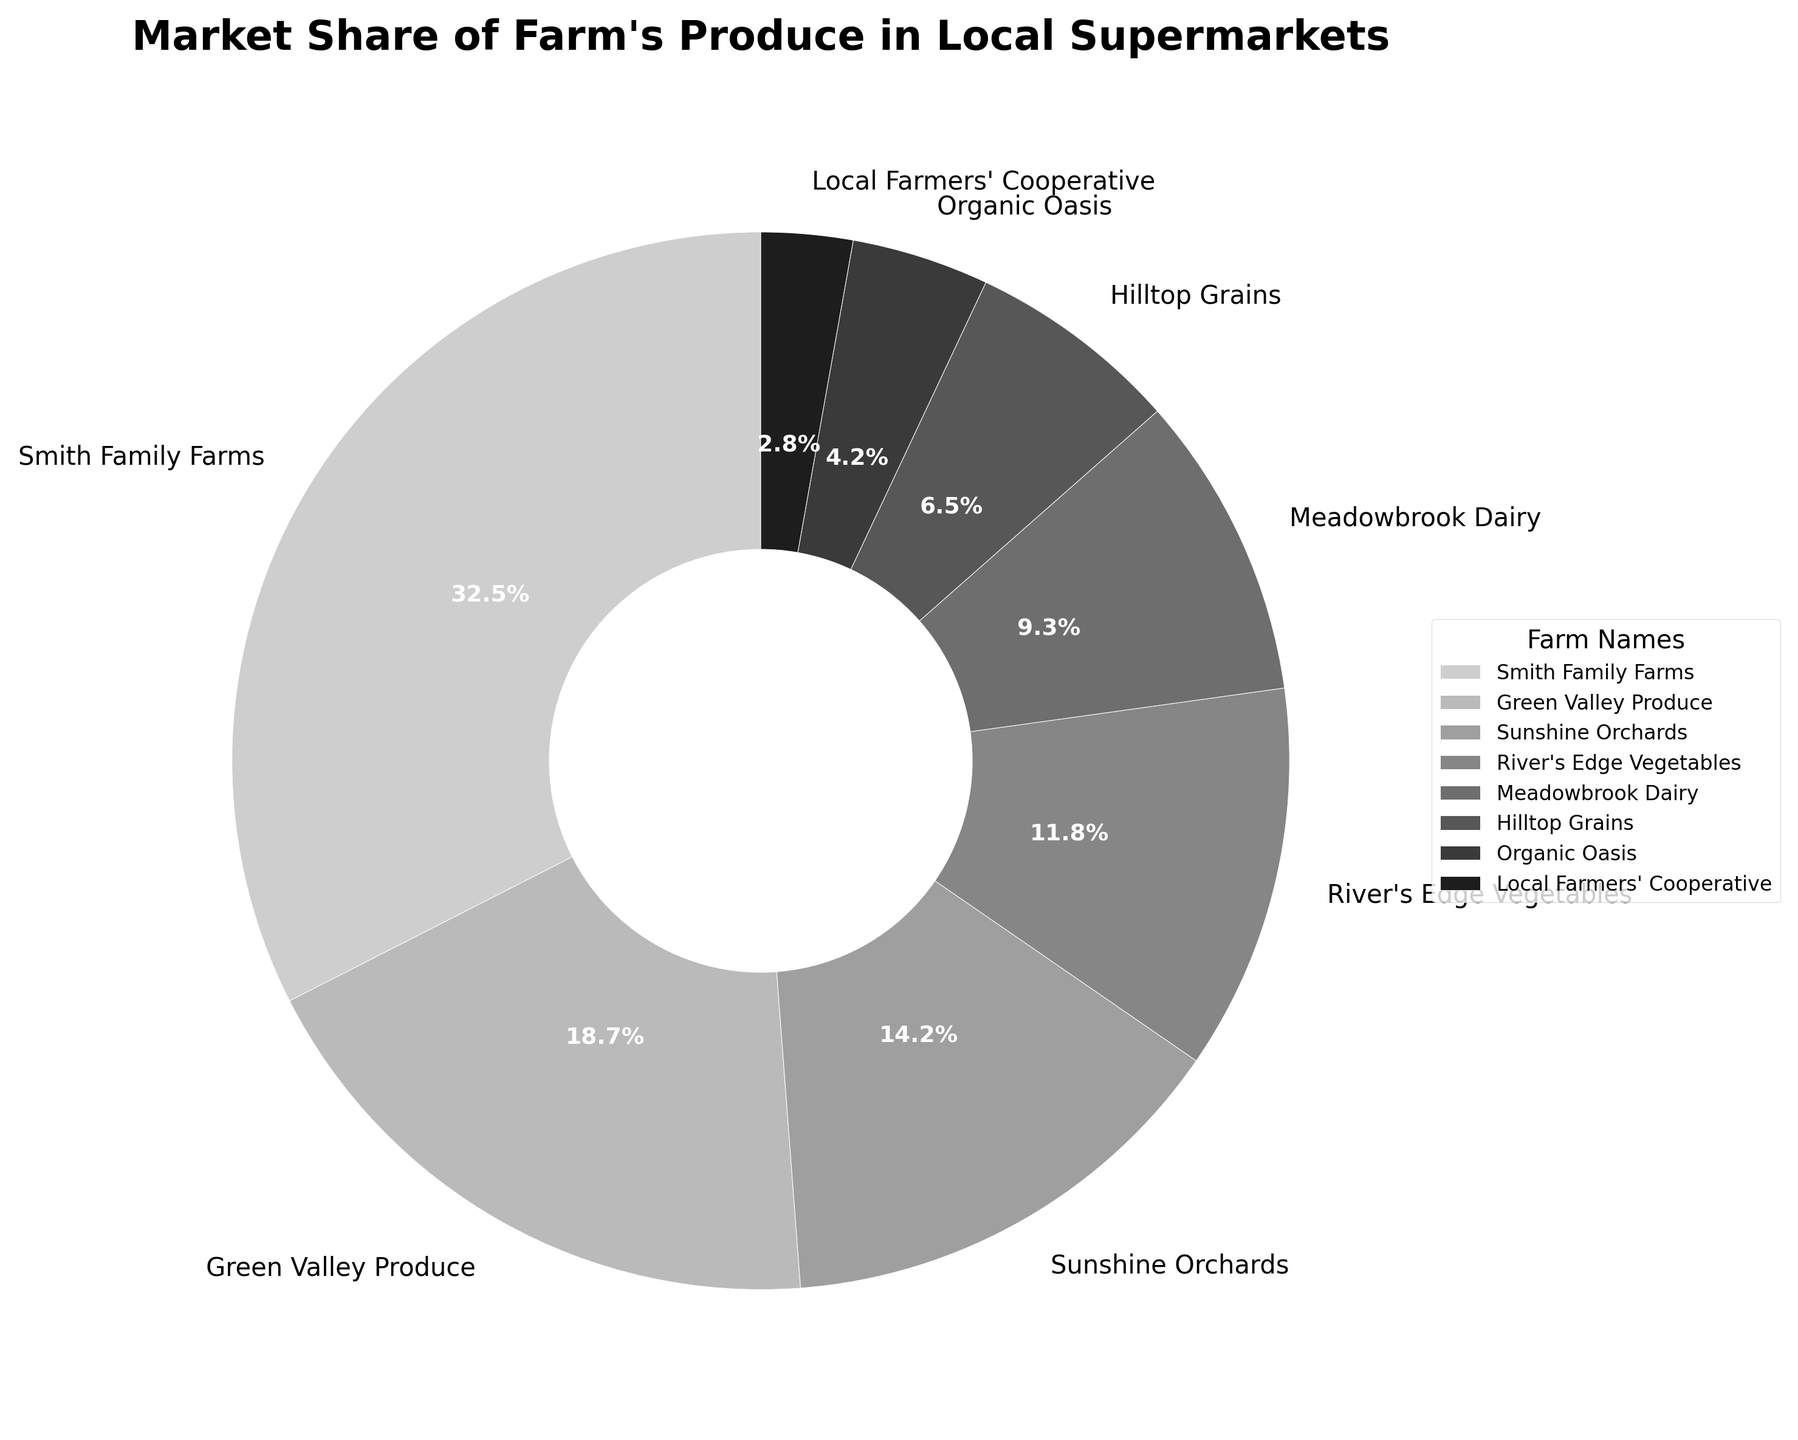Which farm has the largest market share? The Smith Family Farms slice appears to be the largest in the pie chart, indicated by its 32.5% share.
Answer: Smith Family Farms Which farm has the smallest market share? The Local Farmers' Cooperative slice is the smallest in the pie chart, indicated by its 2.8% share.
Answer: Local Farmers' Cooperative What is the total market share of Smith Family Farms and Green Valley Produce combined? Add the market share percentages of Smith Family Farms (32.5%) and Green Valley Produce (18.7%). This results in 32.5 + 18.7 = 51.2.
Answer: 51.2% Is Meadowbrook Dairy's market share more or less than Hilltop Grains'? Compare Meadowbrook Dairy's market share (9.3%) with Hilltop Grains' market share (6.5%). Meadowbrook Dairy has a higher market share.
Answer: More How much larger is Sunshine Orchards' market share compared to Organic Oasis'? Subtract Organic Oasis' market share (4.2%) from Sunshine Orchards' market share (14.2%). The difference is 14.2 - 4.2 = 10.
Answer: 10% What is the average market share of the farms with more than 10% market share? Identify farms with more than 10% market share: Smith Family Farms (32.5%), Green Valley Produce (18.7%), Sunshine Orchards (14.2%), and River's Edge Vegetables (11.8%). Sum these shares: 32.5 + 18.7 + 14.2 + 11.8 = 77.2. Divide by the number of farms (4). The average is 77.2 / 4 = 19.3.
Answer: 19.3% Which two farms have a combined market share closest to 25%? Sum the market shares of possible pairs of farms and find the combination that sums closest to 25%. Considering: Meadowbrook Dairy (9.3%) + Hilltop Grains (6.5%) = 15.8%, or Organic Oasis (4.2%) + River's Edge Vegetables (11.8%) = 16%, which is larger than 15.8%. Next consider smaller farms: Local Farmers' Cooperative (2.8%) + Organic Oasis (4.2%) = 7%. The closest combined share to 25% in this case is Meadowbrook Dairy (9.3%) + River's Edge Vegetables (11.8%) = 21.1%.
Answer: Meadowbrook Dairy and River's Edge Vegetables What percentage of the market share is taken up by the farms not in the top three? Subtract the total market share of the top three farms: Smith Family Farms (32.5%), Green Valley Produce (18.7%), and Sunshine Orchards (14.2%) from 100%. Total of top three is 32.5 + 18.7 + 14.2 = 65.4%. Therefore, 100 - 65.4 = 34.6%.
Answer: 34.6% What is the median market share percentage of all the farms? Arrange the market shares in ascending order: 2.8, 4.2, 6.5, 9.3, 11.8, 14.2, 18.7, 32.5. There are eight farms, so the median would be the average of the 4th and 5th values: (9.3 + 11.8) / 2 = 21.1 / 2 = 10.55
Answer: 10.55% If we group the farms into large (≥10%) and small (<10%) market shares, how many farms are in each group? Large farms (≥10%): Smith Family Farms, Green Valley Produce, Sunshine Orchards, and River's Edge Vegetables (4 farms). Small farms (<10%): Meadowbrook Dairy, Hilltop Grains, Organic Oasis, Local Farmers' Cooperative (4 farms).
Answer: 4 in large, 4 in small 